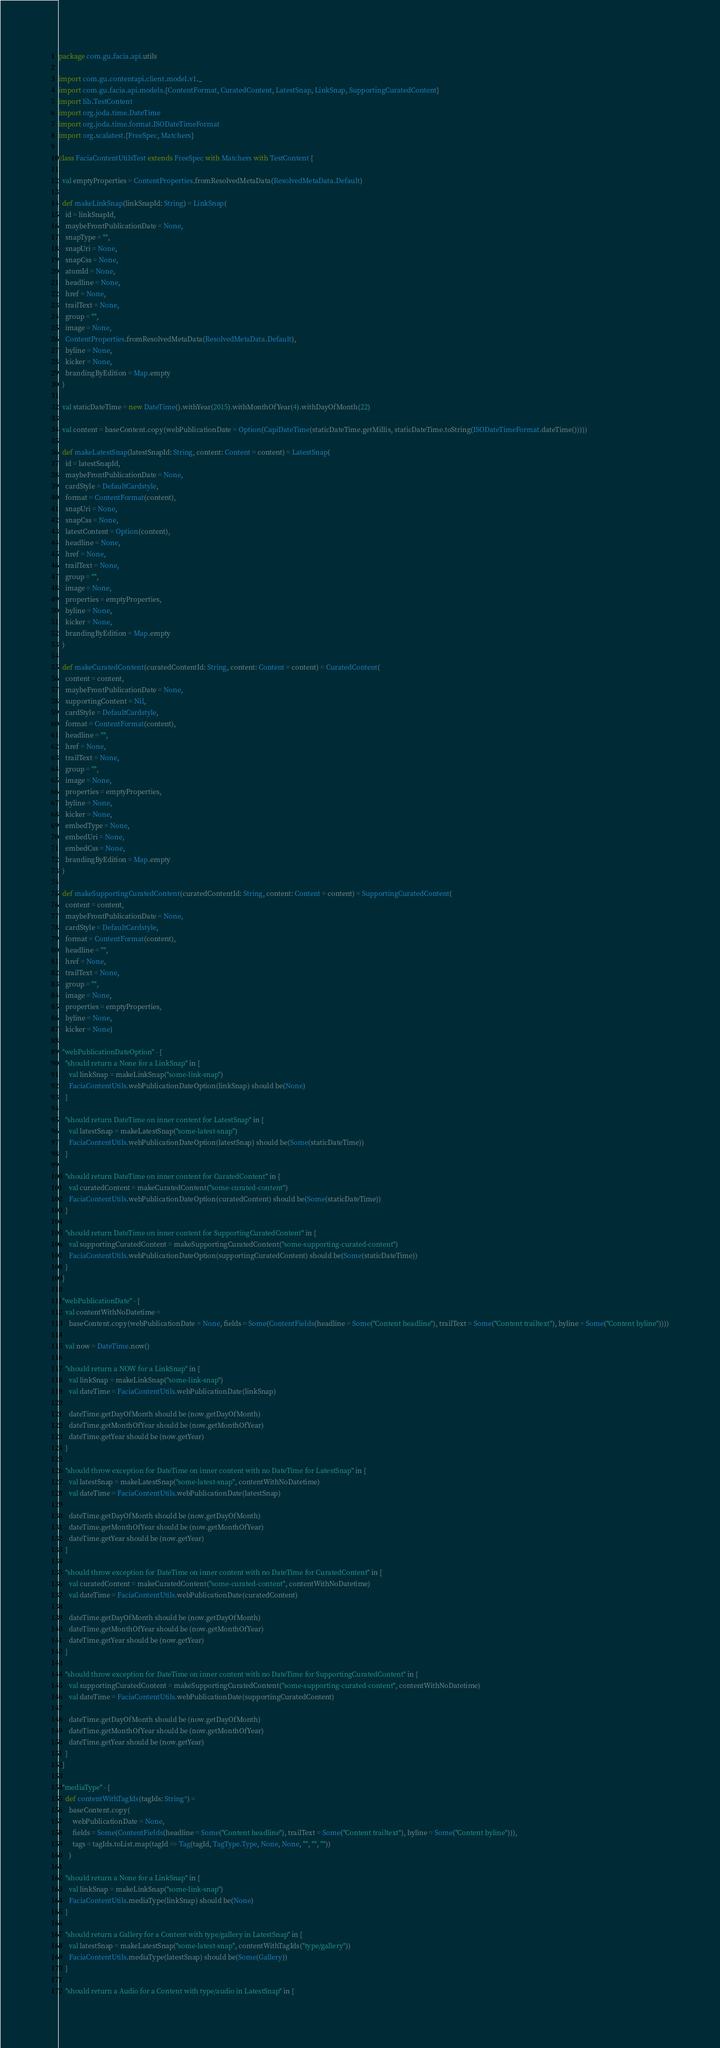<code> <loc_0><loc_0><loc_500><loc_500><_Scala_>package com.gu.facia.api.utils

import com.gu.contentapi.client.model.v1._
import com.gu.facia.api.models.{ContentFormat, CuratedContent, LatestSnap, LinkSnap, SupportingCuratedContent}
import lib.TestContent
import org.joda.time.DateTime
import org.joda.time.format.ISODateTimeFormat
import org.scalatest.{FreeSpec, Matchers}

class FaciaContentUtilsTest extends FreeSpec with Matchers with TestContent {

  val emptyProperties = ContentProperties.fromResolvedMetaData(ResolvedMetaData.Default)

  def makeLinkSnap(linkSnapId: String) = LinkSnap(
    id = linkSnapId,
    maybeFrontPublicationDate = None,
    snapType = "",
    snapUri = None,
    snapCss = None,
    atomId = None,
    headline = None,
    href = None,
    trailText = None,
    group = "",
    image = None,
    ContentProperties.fromResolvedMetaData(ResolvedMetaData.Default),
    byline = None,
    kicker = None,
    brandingByEdition = Map.empty
  )

  val staticDateTime = new DateTime().withYear(2015).withMonthOfYear(4).withDayOfMonth(22)

  val content = baseContent.copy(webPublicationDate = Option(CapiDateTime(staticDateTime.getMillis, staticDateTime.toString(ISODateTimeFormat.dateTime()))))

  def makeLatestSnap(latestSnapId: String, content: Content = content) = LatestSnap(
    id = latestSnapId,
    maybeFrontPublicationDate = None,
    cardStyle = DefaultCardstyle,
    format = ContentFormat(content),
    snapUri = None,
    snapCss = None,
    latestContent = Option(content),
    headline = None,
    href = None,
    trailText = None,
    group = "",
    image = None,
    properties = emptyProperties,
    byline = None,
    kicker = None,
    brandingByEdition = Map.empty
  )

  def makeCuratedContent(curatedContentId: String, content: Content = content) = CuratedContent(
    content = content,
    maybeFrontPublicationDate = None,
    supportingContent = Nil,
    cardStyle = DefaultCardstyle,
    format = ContentFormat(content),
    headline = "",
    href = None,
    trailText = None,
    group = "",
    image = None,
    properties = emptyProperties,
    byline = None,
    kicker = None,
    embedType = None,
    embedUri = None,
    embedCss = None,
    brandingByEdition = Map.empty
  )

  def makeSupportingCuratedContent(curatedContentId: String, content: Content = content) = SupportingCuratedContent(
    content = content,
    maybeFrontPublicationDate = None,
    cardStyle = DefaultCardstyle,
    format = ContentFormat(content),
    headline = "",
    href = None,
    trailText = None,
    group = "",
    image = None,
    properties = emptyProperties,
    byline = None,
    kicker = None)

  "webPublicationDateOption" - {
    "should return a None for a LinkSnap" in {
      val linkSnap = makeLinkSnap("some-link-snap")
      FaciaContentUtils.webPublicationDateOption(linkSnap) should be(None)
    }

    "should return DateTime on inner content for LatestSnap" in {
      val latestSnap = makeLatestSnap("some-latest-snap")
      FaciaContentUtils.webPublicationDateOption(latestSnap) should be(Some(staticDateTime))
    }

    "should return DateTime on inner content for CuratedContent" in {
      val curatedContent = makeCuratedContent("some-curated-content")
      FaciaContentUtils.webPublicationDateOption(curatedContent) should be(Some(staticDateTime))
    }

    "should return DateTime on inner content for SupportingCuratedContent" in {
      val supportingCuratedContent = makeSupportingCuratedContent("some-supporting-curated-content")
      FaciaContentUtils.webPublicationDateOption(supportingCuratedContent) should be(Some(staticDateTime))
    }
  }

  "webPublicationDate" - {
    val contentWithNoDatetime =
      baseContent.copy(webPublicationDate = None, fields = Some(ContentFields(headline = Some("Content headline"), trailText = Some("Content trailtext"), byline = Some("Content byline"))))

    val now = DateTime.now()

    "should return a NOW for a LinkSnap" in {
      val linkSnap = makeLinkSnap("some-link-snap")
      val dateTime = FaciaContentUtils.webPublicationDate(linkSnap)

      dateTime.getDayOfMonth should be (now.getDayOfMonth)
      dateTime.getMonthOfYear should be (now.getMonthOfYear)
      dateTime.getYear should be (now.getYear)
    }

    "should throw exception for DateTime on inner content with no DateTime for LatestSnap" in {
      val latestSnap = makeLatestSnap("some-latest-snap", contentWithNoDatetime)
      val dateTime = FaciaContentUtils.webPublicationDate(latestSnap)

      dateTime.getDayOfMonth should be (now.getDayOfMonth)
      dateTime.getMonthOfYear should be (now.getMonthOfYear)
      dateTime.getYear should be (now.getYear)
    }

    "should throw exception for DateTime on inner content with no DateTime for CuratedContent" in {
      val curatedContent = makeCuratedContent("some-curated-content", contentWithNoDatetime)
      val dateTime = FaciaContentUtils.webPublicationDate(curatedContent)

      dateTime.getDayOfMonth should be (now.getDayOfMonth)
      dateTime.getMonthOfYear should be (now.getMonthOfYear)
      dateTime.getYear should be (now.getYear)
    }

    "should throw exception for DateTime on inner content with no DateTime for SupportingCuratedContent" in {
      val supportingCuratedContent = makeSupportingCuratedContent("some-supporting-curated-content", contentWithNoDatetime)
      val dateTime = FaciaContentUtils.webPublicationDate(supportingCuratedContent)

      dateTime.getDayOfMonth should be (now.getDayOfMonth)
      dateTime.getMonthOfYear should be (now.getMonthOfYear)
      dateTime.getYear should be (now.getYear)
    }
  }

  "mediaType" - {
    def contentWithTagIds(tagIds: String*) =
      baseContent.copy(
        webPublicationDate = None,
        fields = Some(ContentFields(headline = Some("Content headline"), trailText = Some("Content trailtext"), byline = Some("Content byline"))),
        tags = tagIds.toList.map(tagId => Tag(tagId, TagType.Type, None, None, "", "", ""))
      )

    "should return a None for a LinkSnap" in {
      val linkSnap = makeLinkSnap("some-link-snap")
      FaciaContentUtils.mediaType(linkSnap) should be(None)
    }

    "should return a Gallery for a Content with type/gallery in LatestSnap" in {
      val latestSnap = makeLatestSnap("some-latest-snap", contentWithTagIds("type/gallery"))
      FaciaContentUtils.mediaType(latestSnap) should be(Some(Gallery))
    }

    "should return a Audio for a Content with type/audio in LatestSnap" in {</code> 